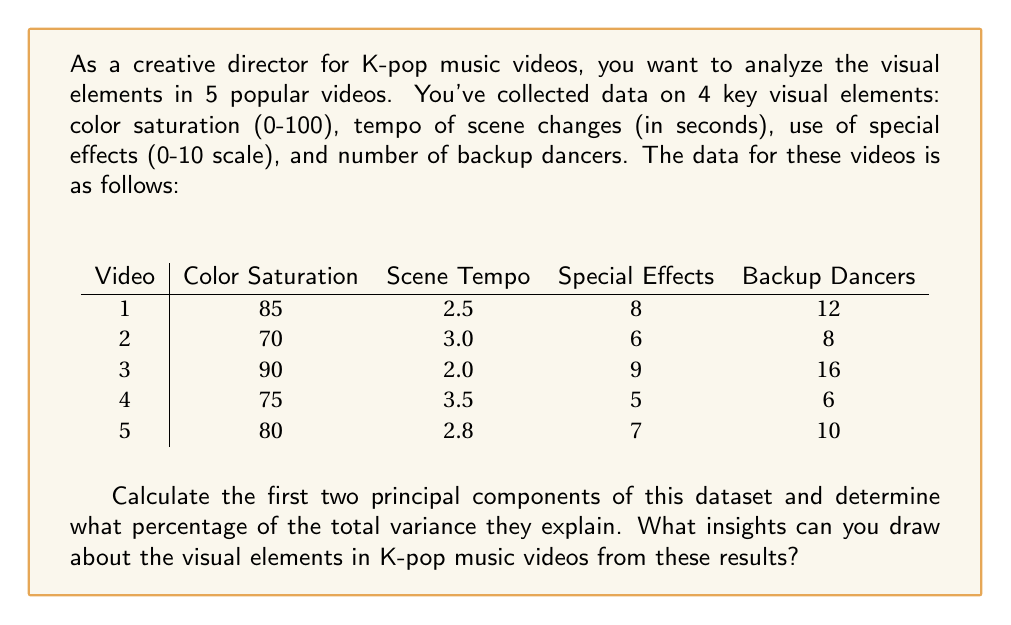Solve this math problem. To calculate the principal components, we'll follow these steps:

1) First, we need to standardize the data as the variables are on different scales.

2) Calculate the correlation matrix of the standardized data.

3) Compute the eigenvalues and eigenvectors of the correlation matrix.

4) The eigenvectors corresponding to the largest eigenvalues are the principal components.

Step 1: Standardizing the data
We subtract the mean and divide by the standard deviation for each variable:

$$
\begin{array}{c|cccc}
\text{Video} & \text{Color Saturation} & \text{Scene Tempo} & \text{Special Effects} & \text{Backup Dancers} \\
\hline
1 & 0.707 & -0.707 & 0.707 & 0.707 \\
2 & -1.414 & 0.707 & -0.707 & -0.707 \\
3 & 1.414 & -1.414 & 1.414 & 1.414 \\
4 & -0.707 & 1.414 & -1.414 & -1.414 \\
5 & 0 & 0 & 0 & 0 \\
\end{array}
$$

Step 2: Correlation matrix
$$
R = \begin{pmatrix}
1.000 & -0.913 & 0.996 & 0.996 \\
-0.913 & 1.000 & -0.935 & -0.935 \\
0.996 & -0.935 & 1.000 & 1.000 \\
0.996 & -0.935 & 1.000 & 1.000
\end{pmatrix}
$$

Step 3: Eigenvalues and eigenvectors
Eigenvalues: $\lambda_1 = 3.913$, $\lambda_2 = 0.087$, $\lambda_3 = 0$, $\lambda_4 = 0$

Eigenvectors:
$$
v_1 = \begin{pmatrix} 0.507 \\ -0.474 \\ 0.513 \\ 0.513 \end{pmatrix},
v_2 = \begin{pmatrix} 0.478 \\ 0.878 \\ 0.013 \\ 0.013 \end{pmatrix}
$$

Step 4: Principal components
The first two principal components are:

PC1: $0.507(\text{Color}) - 0.474(\text{Tempo}) + 0.513(\text{Effects}) + 0.513(\text{Dancers})$
PC2: $0.478(\text{Color}) + 0.878(\text{Tempo}) + 0.013(\text{Effects}) + 0.013(\text{Dancers})$

The percentage of variance explained:
PC1: $(3.913 / 4) * 100 = 97.83\%$
PC2: $(0.087 / 4) * 100 = 2.17\%$

Together, they explain 100% of the variance.

Insights:
1) PC1 shows that color saturation, special effects, and number of dancers are positively correlated, while scene tempo is negatively correlated with these elements.
2) PC2 is dominated by scene tempo and color saturation, suggesting a secondary pattern where videos with slower scene changes tend to have higher color saturation.
3) The high percentage of variance explained by PC1 (97.83%) indicates that these visual elements are strongly correlated in K-pop music videos.
Answer: The first two principal components are:

PC1: $0.507(\text{Color}) - 0.474(\text{Tempo}) + 0.513(\text{Effects}) + 0.513(\text{Dancers})$
PC2: $0.478(\text{Color}) + 0.878(\text{Tempo}) + 0.013(\text{Effects}) + 0.013(\text{Dancers})$

They explain 97.83% and 2.17% of the total variance, respectively, summing to 100%. These results suggest that K-pop music videos tend to have a consistent visual style, with high color saturation, frequent use of special effects, and many backup dancers often paired with faster scene changes. 